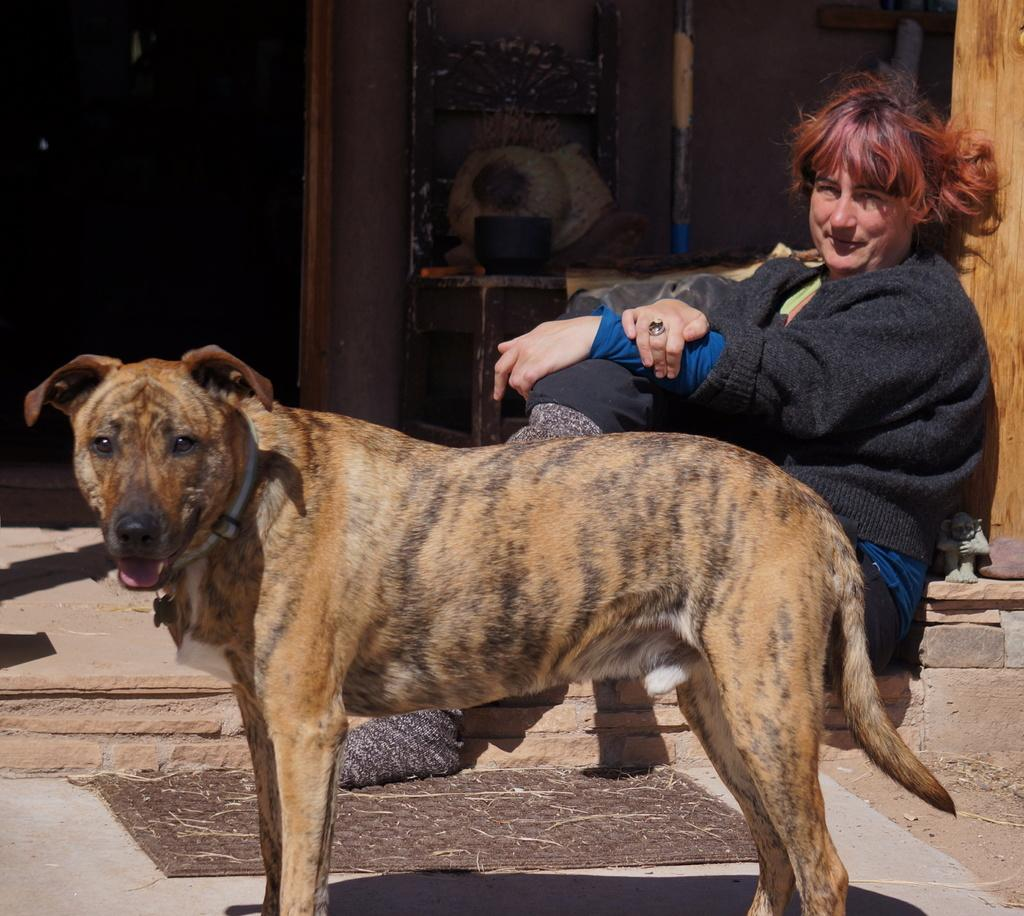Who is present in the image? There is a woman in the image. What is the woman wearing? The woman is wearing a sweater. What is the woman doing in the image? The woman is sitting and smiling. What other living creature is in the image? There is a dog in the image. What is the dog doing in the image? The dog is standing on the floor. What can be seen in the background of the image? There is a wall, a banner, a pole, a table, and a pillar in the background of the image. What type of apparatus is being used by the woman in the image? There is no apparatus present in the image. How many nails can be seen in the image? There are no nails visible in the image. 